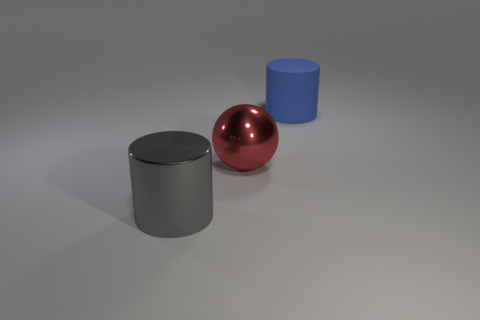Is there anything else that is the same material as the blue cylinder?
Offer a very short reply. No. Is the material of the red thing the same as the cylinder that is left of the blue matte cylinder?
Offer a terse response. Yes. How many objects are both behind the gray metallic cylinder and to the left of the large matte object?
Provide a short and direct response. 1. There is a gray thing that is the same size as the blue thing; what shape is it?
Make the answer very short. Cylinder. Is there a big gray object that is on the right side of the cylinder on the left side of the large object behind the red object?
Offer a terse response. No. There is a matte cylinder; is its color the same as the big cylinder in front of the big matte object?
Give a very brief answer. No. How many cylinders have the same color as the ball?
Your answer should be compact. 0. What is the size of the cylinder left of the big blue matte object that is behind the red ball?
Provide a short and direct response. Large. What number of objects are either objects that are left of the blue cylinder or red things?
Your answer should be compact. 2. Are there any red metal spheres that have the same size as the blue rubber cylinder?
Your answer should be very brief. Yes. 